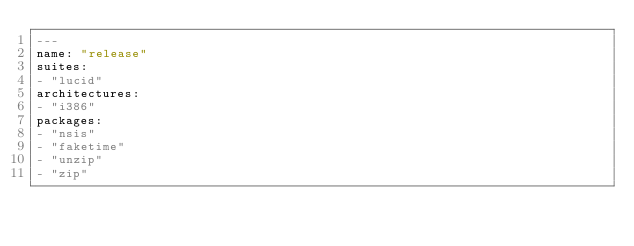<code> <loc_0><loc_0><loc_500><loc_500><_YAML_>---
name: "release"
suites:
- "lucid"
architectures:
- "i386"
packages:
- "nsis"
- "faketime"
- "unzip"
- "zip"</code> 